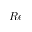Convert formula to latex. <formula><loc_0><loc_0><loc_500><loc_500>R e</formula> 